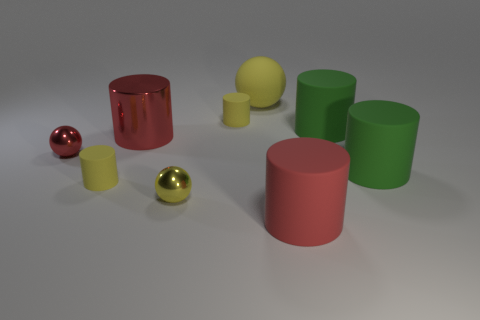What number of big objects are red metal balls or yellow objects?
Offer a terse response. 1. What color is the other small object that is made of the same material as the tiny red object?
Offer a very short reply. Yellow. How many things have the same material as the small red sphere?
Ensure brevity in your answer.  2. There is a red cylinder that is left of the large red rubber cylinder; is it the same size as the green object in front of the small red metal ball?
Make the answer very short. Yes. What is the yellow sphere that is on the left side of the tiny yellow object that is behind the big metal cylinder made of?
Your answer should be compact. Metal. Is the number of red rubber cylinders that are right of the large yellow matte object less than the number of red metal cylinders that are to the right of the big red shiny cylinder?
Give a very brief answer. No. There is a sphere that is the same color as the big metal thing; what is it made of?
Your response must be concise. Metal. Are there any other things that have the same shape as the small red object?
Your response must be concise. Yes. There is a tiny sphere in front of the small red metallic thing; what is its material?
Offer a terse response. Metal. Are there any other things that have the same size as the red shiny sphere?
Make the answer very short. Yes. 